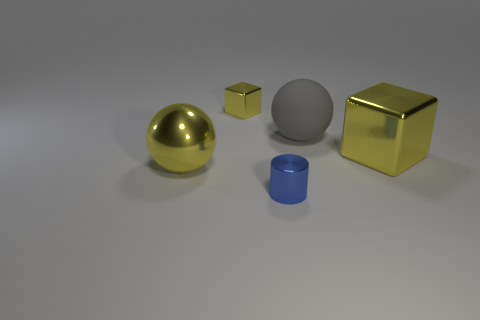Imagine these objects in a real-world setting. What could they represent? In a real-world setting, the golden sphere might be a decorative ornament or a finial. The cube with the matte finish could be a child's block or an artistic paperweight. The blue metallic cylinder resembles a canister or a container of some sort, perhaps for holding pens on a desk. Finally, the golden cube might be a fancy packaging box for a luxury item, or it could be a stylized depiction of a gold bar. 